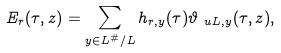Convert formula to latex. <formula><loc_0><loc_0><loc_500><loc_500>E _ { r } ( \tau , z ) & = \sum _ { y \in L ^ { \# } / L } h _ { r , y } ( \tau ) \vartheta _ { \ u L , y } ( \tau , z ) ,</formula> 